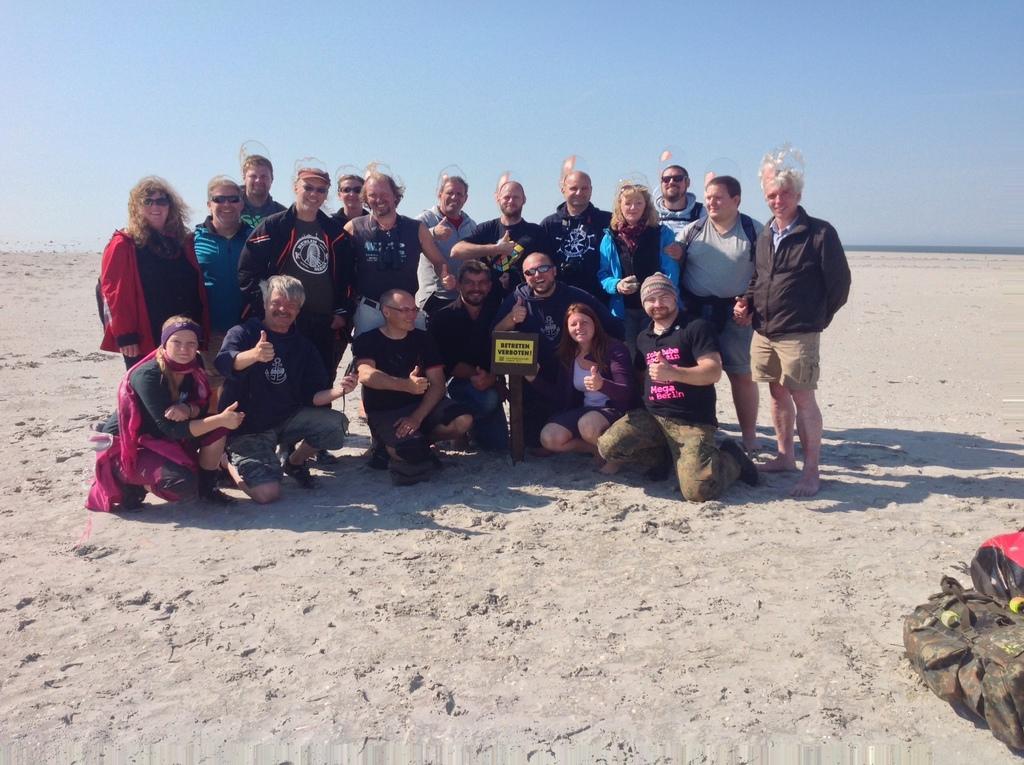In one or two sentences, can you explain what this image depicts? In this image we can see there are a few people sitting on the sand and few people standing. And there is a board and an object. At the top there is the sky. 